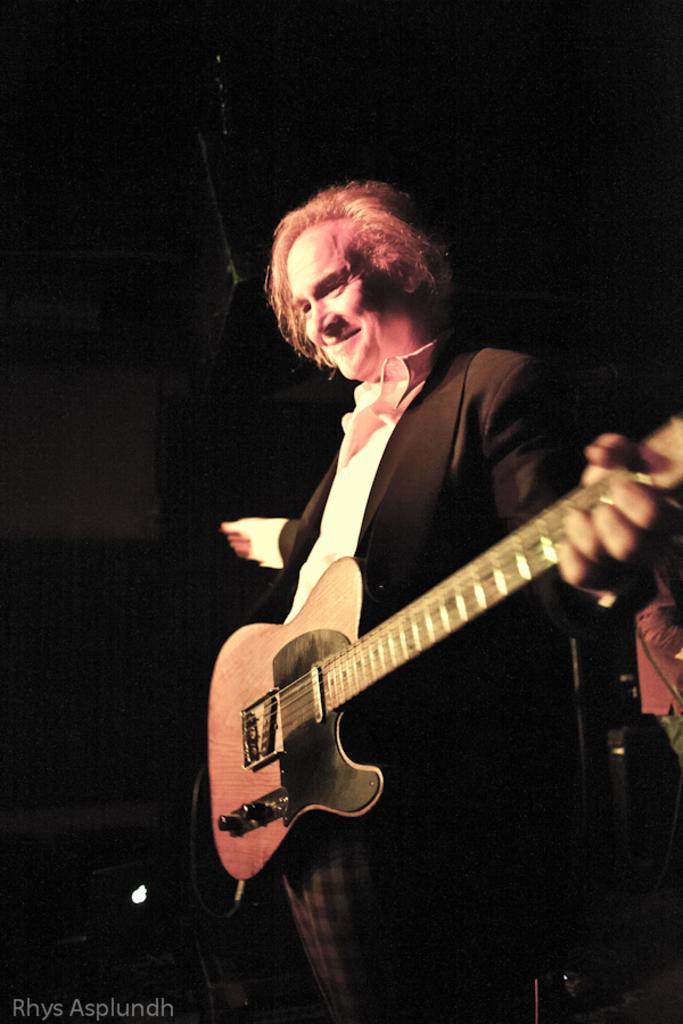In one or two sentences, can you explain what this image depicts? In this picture we have a man standing and holding a guitar. 